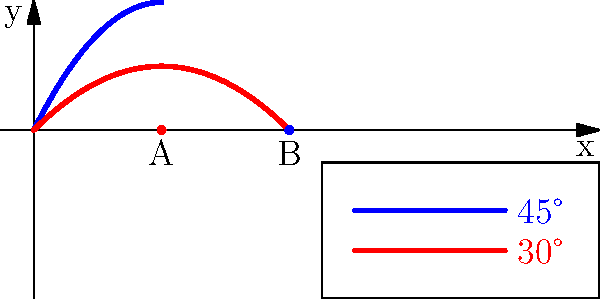In the Doraemon series, Nobita uses the "Time Projectile" gadget to launch objects through time. The graph shows the trajectories of two time-traveling objects launched at different angles. The blue curve represents a launch at 45° and the red curve at 30°. If both objects land at the same moment in time, how many times farther does the 45° projectile travel compared to the 30° projectile? To solve this problem, we need to follow these steps:

1) First, we identify the landing points of both projectiles:
   - 30° projectile (red curve) lands at point A (10, 0)
   - 45° projectile (blue curve) lands at point B (20, 0)

2) The horizontal distance traveled by each projectile is:
   - 30° projectile: 10 units
   - 45° projectile: 20 units

3) To find how many times farther the 45° projectile travels, we divide its distance by the 30° projectile's distance:

   $$\frac{\text{Distance of 45° projectile}}{\text{Distance of 30° projectile}} = \frac{20}{10} = 2$$

Therefore, the 45° projectile travels 2 times farther than the 30° projectile.

This result aligns with the theory that in ideal conditions, a 45° launch angle provides the maximum range, traveling twice the distance of a 30° launch given the same initial velocity.
Answer: 2 times 